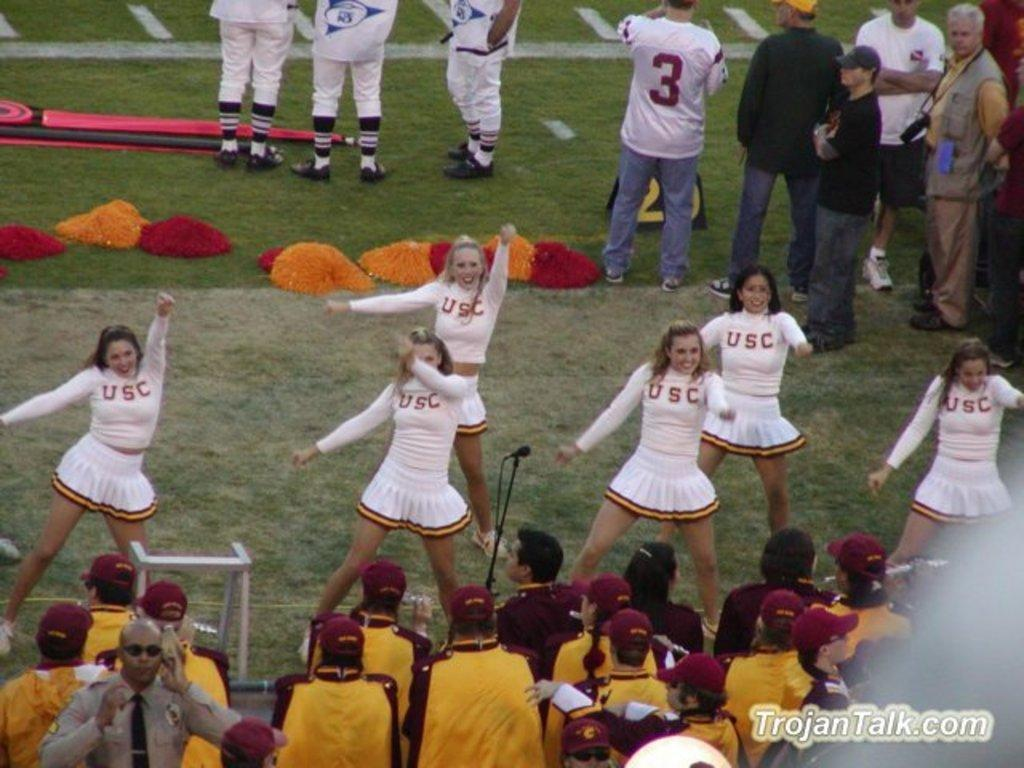Provide a one-sentence caption for the provided image. A group  of USC cheerleaders perform for a crowd at a football game. 